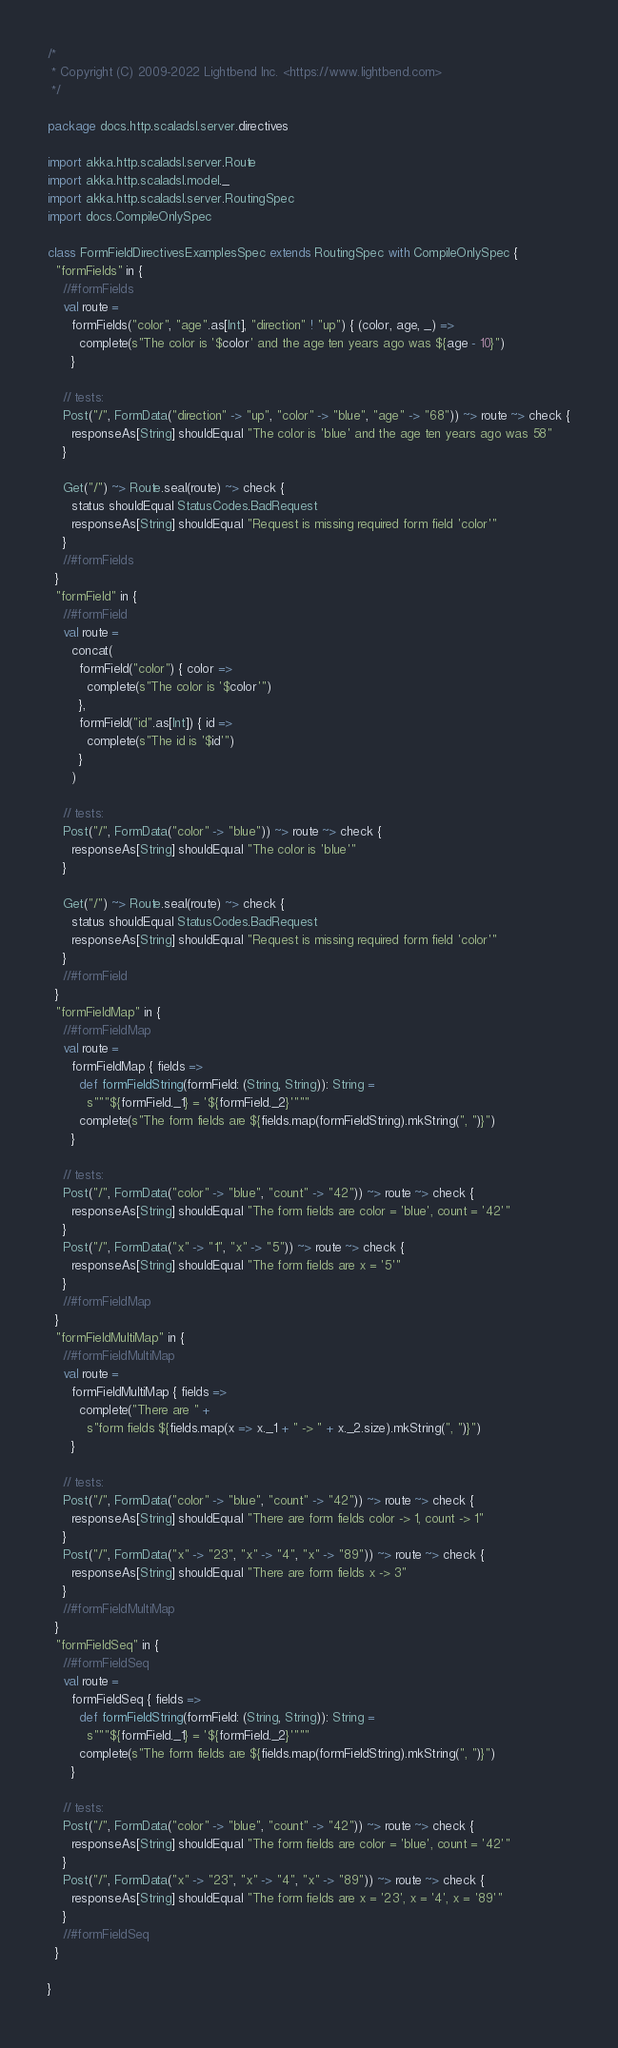Convert code to text. <code><loc_0><loc_0><loc_500><loc_500><_Scala_>/*
 * Copyright (C) 2009-2022 Lightbend Inc. <https://www.lightbend.com>
 */

package docs.http.scaladsl.server.directives

import akka.http.scaladsl.server.Route
import akka.http.scaladsl.model._
import akka.http.scaladsl.server.RoutingSpec
import docs.CompileOnlySpec

class FormFieldDirectivesExamplesSpec extends RoutingSpec with CompileOnlySpec {
  "formFields" in {
    //#formFields
    val route =
      formFields("color", "age".as[Int], "direction" ! "up") { (color, age, _) =>
        complete(s"The color is '$color' and the age ten years ago was ${age - 10}")
      }

    // tests:
    Post("/", FormData("direction" -> "up", "color" -> "blue", "age" -> "68")) ~> route ~> check {
      responseAs[String] shouldEqual "The color is 'blue' and the age ten years ago was 58"
    }

    Get("/") ~> Route.seal(route) ~> check {
      status shouldEqual StatusCodes.BadRequest
      responseAs[String] shouldEqual "Request is missing required form field 'color'"
    }
    //#formFields
  }
  "formField" in {
    //#formField
    val route =
      concat(
        formField("color") { color =>
          complete(s"The color is '$color'")
        },
        formField("id".as[Int]) { id =>
          complete(s"The id is '$id'")
        }
      )

    // tests:
    Post("/", FormData("color" -> "blue")) ~> route ~> check {
      responseAs[String] shouldEqual "The color is 'blue'"
    }

    Get("/") ~> Route.seal(route) ~> check {
      status shouldEqual StatusCodes.BadRequest
      responseAs[String] shouldEqual "Request is missing required form field 'color'"
    }
    //#formField
  }
  "formFieldMap" in {
    //#formFieldMap
    val route =
      formFieldMap { fields =>
        def formFieldString(formField: (String, String)): String =
          s"""${formField._1} = '${formField._2}'"""
        complete(s"The form fields are ${fields.map(formFieldString).mkString(", ")}")
      }

    // tests:
    Post("/", FormData("color" -> "blue", "count" -> "42")) ~> route ~> check {
      responseAs[String] shouldEqual "The form fields are color = 'blue', count = '42'"
    }
    Post("/", FormData("x" -> "1", "x" -> "5")) ~> route ~> check {
      responseAs[String] shouldEqual "The form fields are x = '5'"
    }
    //#formFieldMap
  }
  "formFieldMultiMap" in {
    //#formFieldMultiMap
    val route =
      formFieldMultiMap { fields =>
        complete("There are " +
          s"form fields ${fields.map(x => x._1 + " -> " + x._2.size).mkString(", ")}")
      }

    // tests:
    Post("/", FormData("color" -> "blue", "count" -> "42")) ~> route ~> check {
      responseAs[String] shouldEqual "There are form fields color -> 1, count -> 1"
    }
    Post("/", FormData("x" -> "23", "x" -> "4", "x" -> "89")) ~> route ~> check {
      responseAs[String] shouldEqual "There are form fields x -> 3"
    }
    //#formFieldMultiMap
  }
  "formFieldSeq" in {
    //#formFieldSeq
    val route =
      formFieldSeq { fields =>
        def formFieldString(formField: (String, String)): String =
          s"""${formField._1} = '${formField._2}'"""
        complete(s"The form fields are ${fields.map(formFieldString).mkString(", ")}")
      }

    // tests:
    Post("/", FormData("color" -> "blue", "count" -> "42")) ~> route ~> check {
      responseAs[String] shouldEqual "The form fields are color = 'blue', count = '42'"
    }
    Post("/", FormData("x" -> "23", "x" -> "4", "x" -> "89")) ~> route ~> check {
      responseAs[String] shouldEqual "The form fields are x = '23', x = '4', x = '89'"
    }
    //#formFieldSeq
  }

}
</code> 